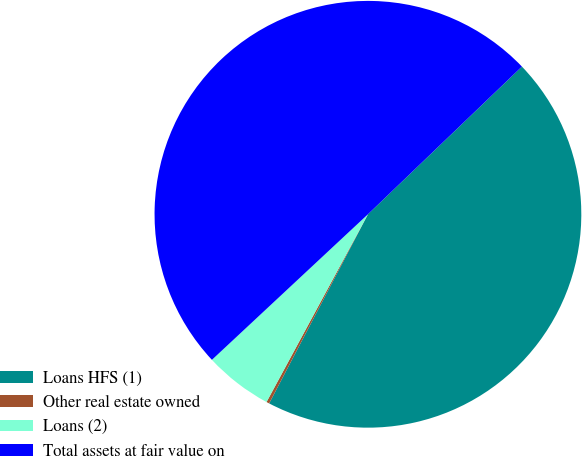<chart> <loc_0><loc_0><loc_500><loc_500><pie_chart><fcel>Loans HFS (1)<fcel>Other real estate owned<fcel>Loans (2)<fcel>Total assets at fair value on<nl><fcel>44.83%<fcel>0.22%<fcel>5.17%<fcel>49.78%<nl></chart> 